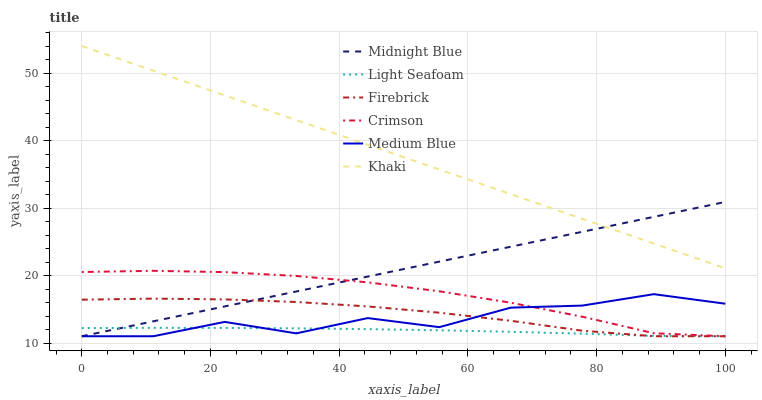Does Midnight Blue have the minimum area under the curve?
Answer yes or no. No. Does Midnight Blue have the maximum area under the curve?
Answer yes or no. No. Is Firebrick the smoothest?
Answer yes or no. No. Is Firebrick the roughest?
Answer yes or no. No. Does Midnight Blue have the highest value?
Answer yes or no. No. Is Light Seafoam less than Khaki?
Answer yes or no. Yes. Is Khaki greater than Medium Blue?
Answer yes or no. Yes. Does Light Seafoam intersect Khaki?
Answer yes or no. No. 